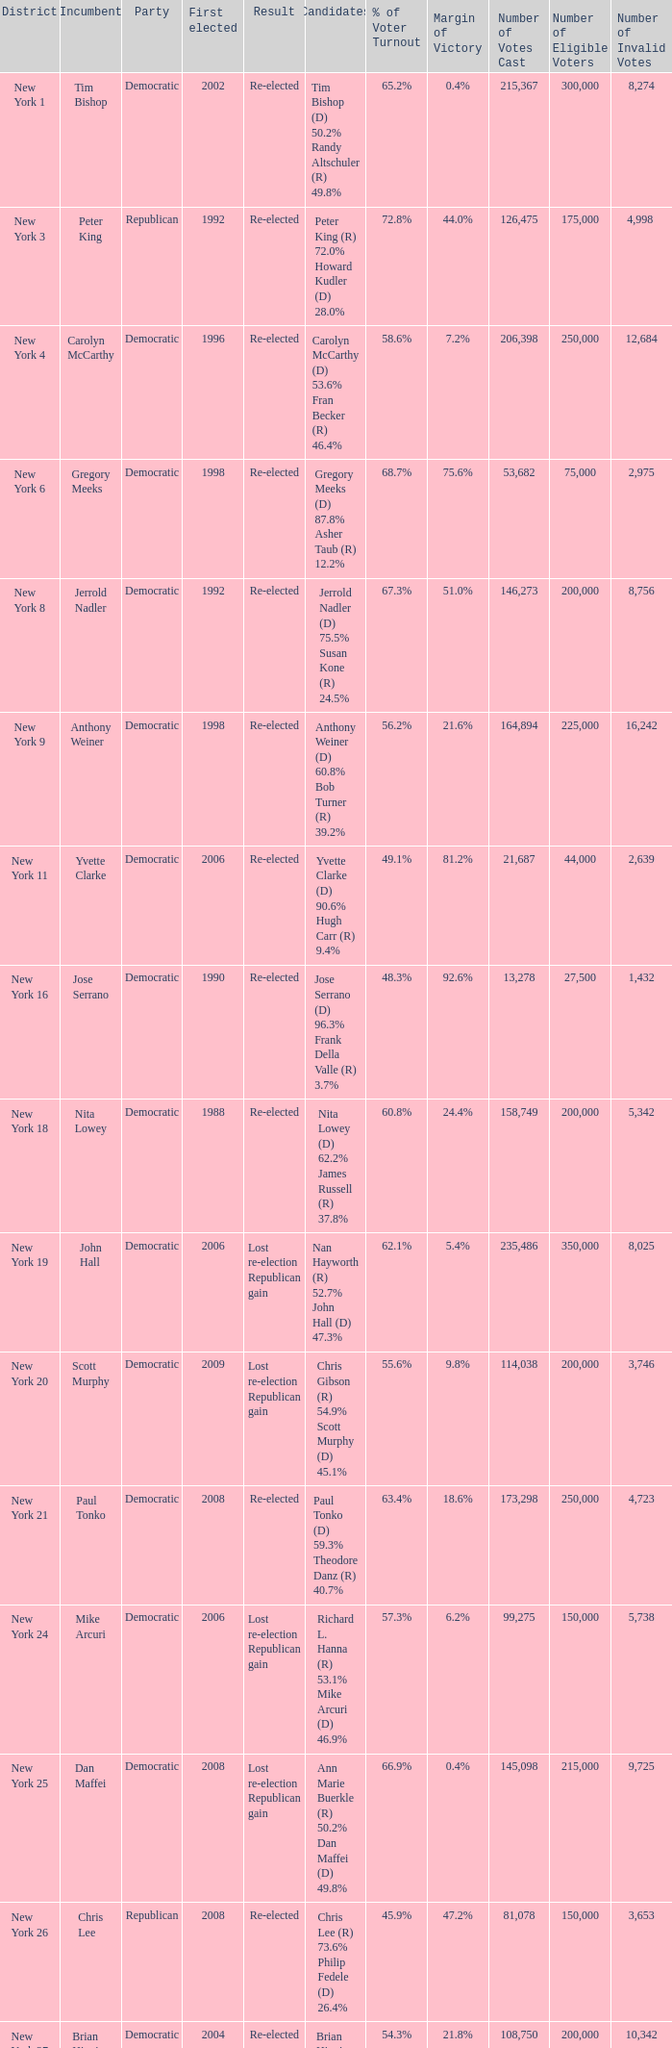Would you be able to parse every entry in this table? {'header': ['District', 'Incumbent', 'Party', 'First elected', 'Result', 'Candidates', '% of Voter Turnout', 'Margin of Victory', 'Number of Votes Cast', 'Number of Eligible Voters', 'Number of Invalid Votes'], 'rows': [['New York 1', 'Tim Bishop', 'Democratic', '2002', 'Re-elected', 'Tim Bishop (D) 50.2% Randy Altschuler (R) 49.8%', '65.2%', '0.4%', '215,367', '300,000', '8,274'], ['New York 3', 'Peter King', 'Republican', '1992', 'Re-elected', 'Peter King (R) 72.0% Howard Kudler (D) 28.0%', '72.8%', '44.0%', '126,475', '175,000', '4,998 '], ['New York 4', 'Carolyn McCarthy', 'Democratic', '1996', 'Re-elected', 'Carolyn McCarthy (D) 53.6% Fran Becker (R) 46.4%', '58.6%', '7.2%', '206,398', '250,000', '12,684'], ['New York 6', 'Gregory Meeks', 'Democratic', '1998', 'Re-elected', 'Gregory Meeks (D) 87.8% Asher Taub (R) 12.2%', '68.7%', '75.6%', '53,682', '75,000', '2,975'], ['New York 8', 'Jerrold Nadler', 'Democratic', '1992', 'Re-elected', 'Jerrold Nadler (D) 75.5% Susan Kone (R) 24.5%', '67.3%', '51.0%', '146,273', '200,000', '8,756'], ['New York 9', 'Anthony Weiner', 'Democratic', '1998', 'Re-elected', 'Anthony Weiner (D) 60.8% Bob Turner (R) 39.2%', '56.2%', '21.6%', '164,894', '225,000', '16,242'], ['New York 11', 'Yvette Clarke', 'Democratic', '2006', 'Re-elected', 'Yvette Clarke (D) 90.6% Hugh Carr (R) 9.4%', '49.1%', '81.2%', '21,687', '44,000', '2,639'], ['New York 16', 'Jose Serrano', 'Democratic', '1990', 'Re-elected', 'Jose Serrano (D) 96.3% Frank Della Valle (R) 3.7%', '48.3%', '92.6%', '13,278', '27,500', '1,432'], ['New York 18', 'Nita Lowey', 'Democratic', '1988', 'Re-elected', 'Nita Lowey (D) 62.2% James Russell (R) 37.8%', '60.8%', '24.4%', '158,749', '200,000', '5,342'], ['New York 19', 'John Hall', 'Democratic', '2006', 'Lost re-election Republican gain', 'Nan Hayworth (R) 52.7% John Hall (D) 47.3%', '62.1%', '5.4%', '235,486', '350,000', '8,025'], ['New York 20', 'Scott Murphy', 'Democratic', '2009', 'Lost re-election Republican gain', 'Chris Gibson (R) 54.9% Scott Murphy (D) 45.1%', '55.6%', '9.8%', '114,038', '200,000', '3,746'], ['New York 21', 'Paul Tonko', 'Democratic', '2008', 'Re-elected', 'Paul Tonko (D) 59.3% Theodore Danz (R) 40.7%', '63.4%', '18.6%', '173,298', '250,000', '4,723'], ['New York 24', 'Mike Arcuri', 'Democratic', '2006', 'Lost re-election Republican gain', 'Richard L. Hanna (R) 53.1% Mike Arcuri (D) 46.9%', '57.3%', '6.2%', '99,275', '150,000', '5,738'], ['New York 25', 'Dan Maffei', 'Democratic', '2008', 'Lost re-election Republican gain', 'Ann Marie Buerkle (R) 50.2% Dan Maffei (D) 49.8%', '66.9%', '0.4%', '145,098', '215,000', '9,725'], ['New York 26', 'Chris Lee', 'Republican', '2008', 'Re-elected', 'Chris Lee (R) 73.6% Philip Fedele (D) 26.4%', '45.9%', '47.2%', '81,078', '150,000', '3,653'], ['New York 27', 'Brian Higgins', 'Democratic', '2004', 'Re-elected', 'Brian Higgins (D) 60.9% Leonard Roberto (R) 39.1%', '54.3%', '21.8%', '108,750', '200,000', '10,342'], ['New York 28', 'Louise Slaughter', 'Democratic', '1986', 'Re-elected', 'Louise Slaughter (D) 64.9% Jill Rowland (R) 35.1%', '57.8%', '29.8%', '190,237', '300,000', '6,925']]} Name the party for new york 4 Democratic. 